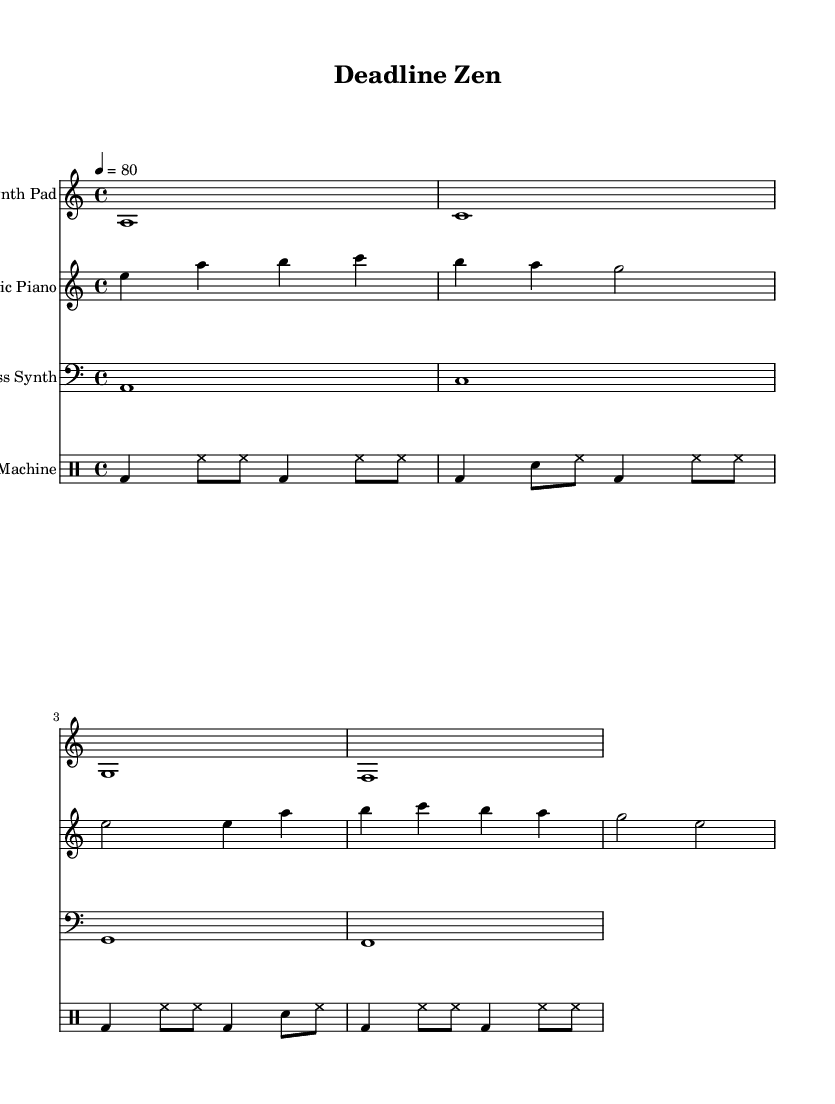What is the key signature of this music? The key signature can be identified at the beginning of the sheet music. It is indicated by the "a" in the key signature and shows that there are no sharps or flats, indicating it is in A minor.
Answer: A minor What is the time signature of this music? The time signature is typically found after the clefs. Here, it is noted as 4/4, which means there are four beats in a measure and a quarter note receives one beat.
Answer: 4/4 What is the tempo marking of this music? The tempo is indicated in the score by "4 = 80", which means that the quarter note gets 80 beats per minute. This gives a clear understanding of the speed at which the piece should be played.
Answer: 80 How many measures are in the synth pad section? By counting the number of vertical lines that separate the notes in the synth pad section, we see that there are four measures, as each measure is divided by a bar line.
Answer: 4 What type of musical instrument is used for the bass part? The instrument specified for the bass part is indicated by the clef used. The bass clef tells us it is a bass synth, an electronic instrument designed to produce low frequencies.
Answer: Bass Synth What rhythmic pattern does the drum machine primarily use? By analyzing the drum machine part, we observe a repetitive pattern with a mixture of bass drum (bd), snare drum (sn), and hi-hat (hh). This shows it follows a consistent rhythm that underlies the electronic style.
Answer: Repetitive What is the highest pitch note in the electric piano part? The electric piano section has various notes, and by identifying the notes written in the staff, we see that the highest pitch note is "c", which is located at the top of the climbing notes in the staff.
Answer: C 